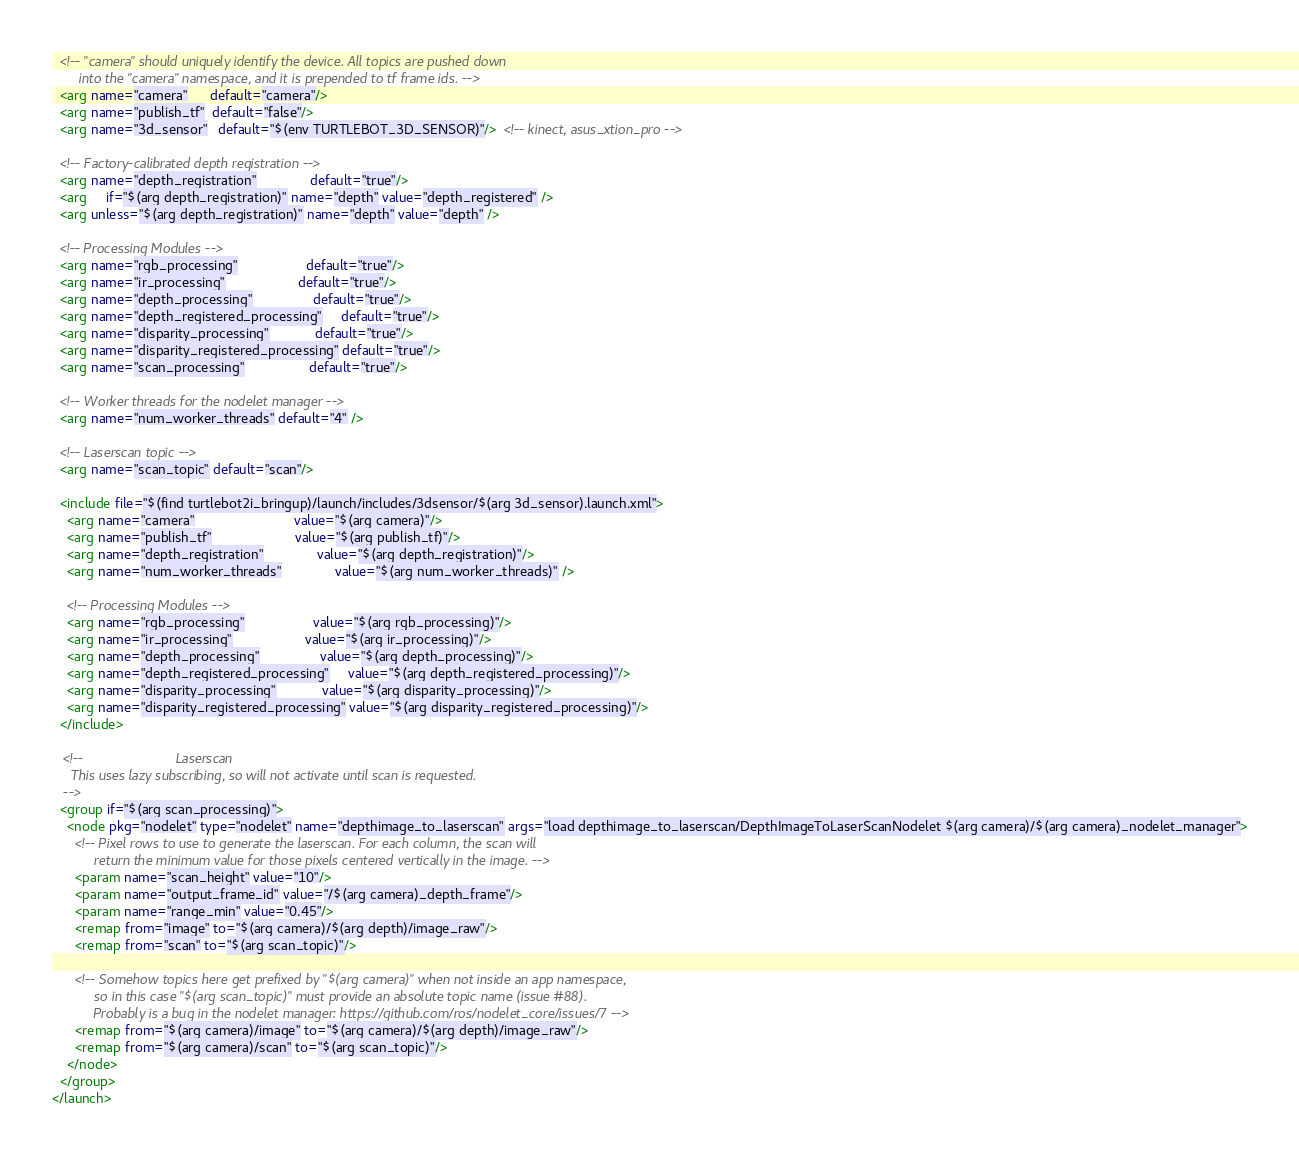Convert code to text. <code><loc_0><loc_0><loc_500><loc_500><_XML_>  <!-- "camera" should uniquely identify the device. All topics are pushed down
       into the "camera" namespace, and it is prepended to tf frame ids. -->
  <arg name="camera"      default="camera"/>
  <arg name="publish_tf"  default="false"/>
  <arg name="3d_sensor"   default="$(env TURTLEBOT_3D_SENSOR)"/>  <!-- kinect, asus_xtion_pro -->

  <!-- Factory-calibrated depth registration -->
  <arg name="depth_registration"              default="true"/>
  <arg     if="$(arg depth_registration)" name="depth" value="depth_registered" />
  <arg unless="$(arg depth_registration)" name="depth" value="depth" />

  <!-- Processing Modules -->
  <arg name="rgb_processing"                  default="true"/>
  <arg name="ir_processing"                   default="true"/>
  <arg name="depth_processing"                default="true"/>
  <arg name="depth_registered_processing"     default="true"/>
  <arg name="disparity_processing"            default="true"/>
  <arg name="disparity_registered_processing" default="true"/>
  <arg name="scan_processing"                 default="true"/>

  <!-- Worker threads for the nodelet manager -->
  <arg name="num_worker_threads" default="4" />

  <!-- Laserscan topic -->
  <arg name="scan_topic" default="scan"/>

  <include file="$(find turtlebot2i_bringup)/launch/includes/3dsensor/$(arg 3d_sensor).launch.xml">
    <arg name="camera"                          value="$(arg camera)"/>
    <arg name="publish_tf"                      value="$(arg publish_tf)"/>
    <arg name="depth_registration"              value="$(arg depth_registration)"/>
    <arg name="num_worker_threads"              value="$(arg num_worker_threads)" />

    <!-- Processing Modules -->
    <arg name="rgb_processing"                  value="$(arg rgb_processing)"/>
    <arg name="ir_processing"                   value="$(arg ir_processing)"/>
    <arg name="depth_processing"                value="$(arg depth_processing)"/>
    <arg name="depth_registered_processing"     value="$(arg depth_registered_processing)"/>
    <arg name="disparity_processing"            value="$(arg disparity_processing)"/>
    <arg name="disparity_registered_processing" value="$(arg disparity_registered_processing)"/>
  </include>

   <!--                        Laserscan 
     This uses lazy subscribing, so will not activate until scan is requested.
   -->
  <group if="$(arg scan_processing)">
    <node pkg="nodelet" type="nodelet" name="depthimage_to_laserscan" args="load depthimage_to_laserscan/DepthImageToLaserScanNodelet $(arg camera)/$(arg camera)_nodelet_manager">
      <!-- Pixel rows to use to generate the laserscan. For each column, the scan will
           return the minimum value for those pixels centered vertically in the image. -->
      <param name="scan_height" value="10"/>
      <param name="output_frame_id" value="/$(arg camera)_depth_frame"/>
      <param name="range_min" value="0.45"/>
      <remap from="image" to="$(arg camera)/$(arg depth)/image_raw"/>
      <remap from="scan" to="$(arg scan_topic)"/>

      <!-- Somehow topics here get prefixed by "$(arg camera)" when not inside an app namespace,
           so in this case "$(arg scan_topic)" must provide an absolute topic name (issue #88).
           Probably is a bug in the nodelet manager: https://github.com/ros/nodelet_core/issues/7 -->
      <remap from="$(arg camera)/image" to="$(arg camera)/$(arg depth)/image_raw"/>
      <remap from="$(arg camera)/scan" to="$(arg scan_topic)"/>
    </node>
  </group>
</launch>
</code> 